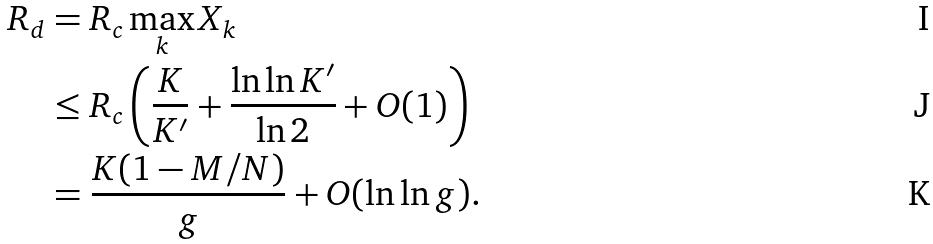<formula> <loc_0><loc_0><loc_500><loc_500>R _ { d } & = R _ { c } \max _ { k } X _ { k } \\ & \leq R _ { c } \left ( \frac { K } { K ^ { \prime } } + \frac { \ln \ln K ^ { \prime } } { \ln 2 } + O ( 1 ) \right ) \\ & = \frac { K ( 1 - M / N ) } { g } + O ( \ln \ln g ) .</formula> 